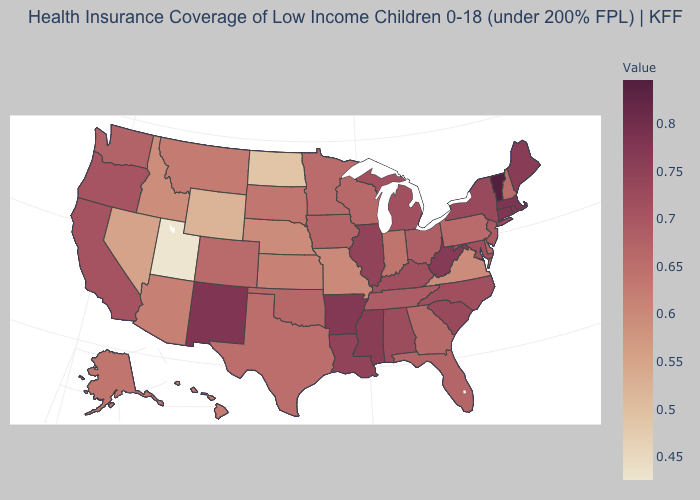Is the legend a continuous bar?
Short answer required. Yes. Which states hav the highest value in the MidWest?
Give a very brief answer. Illinois. Which states have the highest value in the USA?
Answer briefly. Vermont. Among the states that border Indiana , which have the lowest value?
Be succinct. Ohio. Among the states that border Florida , which have the highest value?
Answer briefly. Alabama. Does Utah have the lowest value in the USA?
Answer briefly. Yes. Among the states that border Kansas , does Oklahoma have the highest value?
Write a very short answer. Yes. 